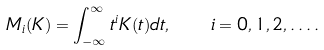Convert formula to latex. <formula><loc_0><loc_0><loc_500><loc_500>M _ { i } ( K ) = \int _ { - \infty } ^ { \infty } t ^ { i } K ( t ) d t , \quad i = 0 , 1 , 2 , \dots .</formula> 